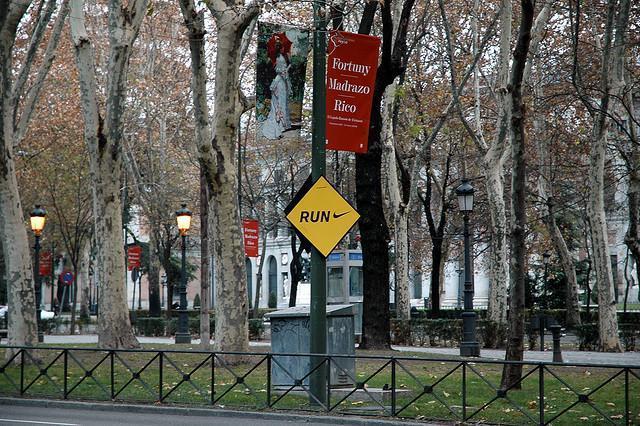How many street lamps are lit?
Give a very brief answer. 2. 